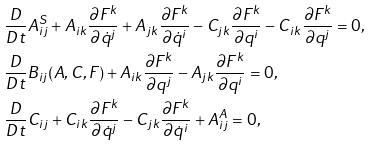Convert formula to latex. <formula><loc_0><loc_0><loc_500><loc_500>& \frac { D } { D t } A ^ { S } _ { i j } + A _ { i k } \frac { \partial F ^ { k } } { \partial { \dot { q } } ^ { j } } + A _ { j k } \frac { \partial F ^ { k } } { \partial { \dot { q } } ^ { i } } - C _ { j k } \frac { \partial F ^ { k } } { \partial { q } ^ { i } } - C _ { i k } \frac { \partial F ^ { k } } { \partial { q } ^ { j } } = 0 , \\ & \frac { D } { D t } B _ { i j } ( A , C , F ) + A _ { i k } \frac { \partial F ^ { k } } { \partial { q } ^ { j } } - A _ { j k } \frac { \partial F ^ { k } } { \partial { q } ^ { i } } = 0 , \\ & \frac { D } { D t } C _ { i j } + C _ { i k } \frac { \partial F ^ { k } } { \partial { \dot { q } } ^ { j } } - C _ { j k } \frac { \partial F ^ { k } } { \partial { \dot { q } } ^ { i } } + A ^ { A } _ { i j } = 0 ,</formula> 